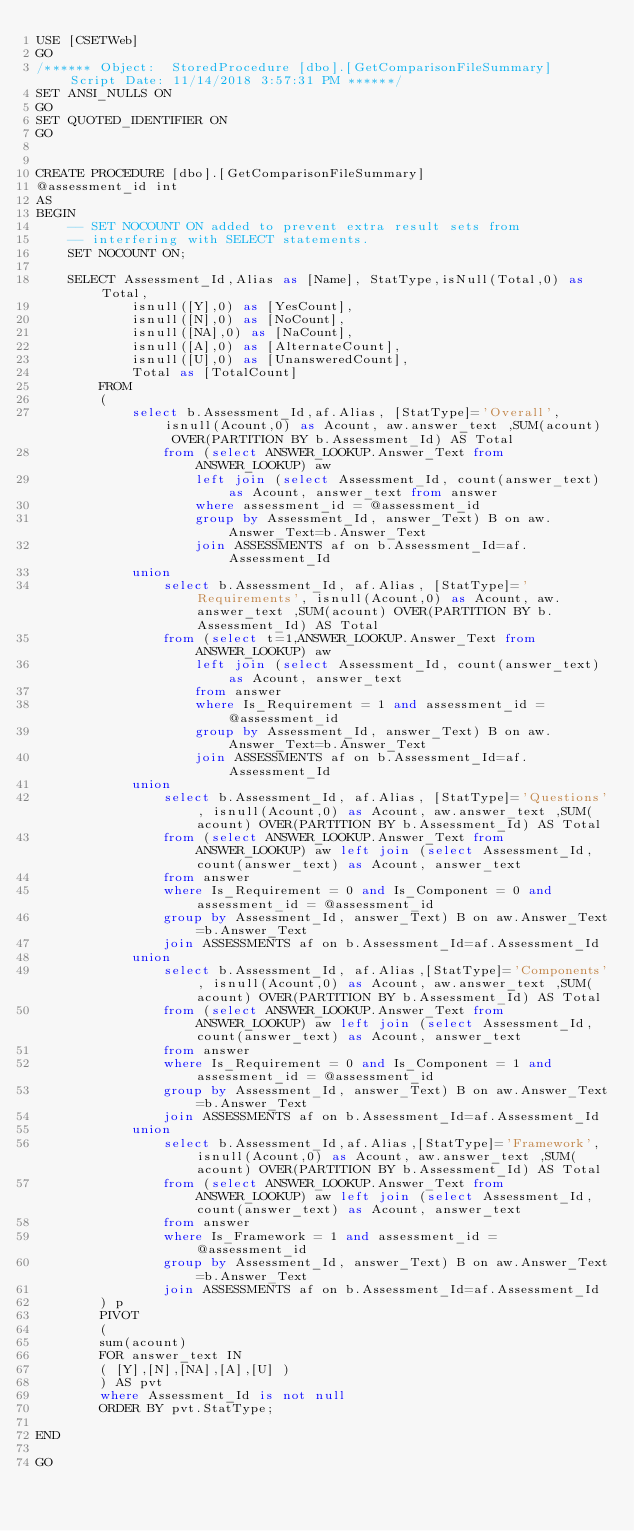Convert code to text. <code><loc_0><loc_0><loc_500><loc_500><_SQL_>USE [CSETWeb]
GO
/****** Object:  StoredProcedure [dbo].[GetComparisonFileSummary]    Script Date: 11/14/2018 3:57:31 PM ******/
SET ANSI_NULLS ON
GO
SET QUOTED_IDENTIFIER ON
GO


CREATE PROCEDURE [dbo].[GetComparisonFileSummary]	
@assessment_id int
AS
BEGIN
	-- SET NOCOUNT ON added to prevent extra result sets from
	-- interfering with SELECT statements.
	SET NOCOUNT ON;

	SELECT Assessment_Id,Alias as [Name], StatType,isNull(Total,0) as Total, 
			isnull([Y],0) as [YesCount],			
			isnull([N],0) as [NoCount],
			isnull([NA],0) as [NaCount],
			isnull([A],0) as [AlternateCount],
			isnull([U],0) as [UnansweredCount],			
			Total as [TotalCount]
		FROM 
		(
			select b.Assessment_Id,af.Alias, [StatType]='Overall', isnull(Acount,0) as Acount, aw.answer_text ,SUM(acount) OVER(PARTITION BY b.Assessment_Id) AS Total  
				from (select ANSWER_LOOKUP.Answer_Text from ANSWER_LOOKUP) aw 
					left join (select Assessment_Id, count(answer_text) as Acount, answer_text from answer 
					where assessment_id = @assessment_id
					group by Assessment_Id, answer_Text) B on aw.Answer_Text=b.Answer_Text 
					join ASSESSMENTS af on b.Assessment_Id=af.Assessment_Id
			union
				select b.Assessment_Id, af.Alias, [StatType]='Requirements', isnull(Acount,0) as Acount, aw.answer_text ,SUM(acount) OVER(PARTITION BY b.Assessment_Id) AS Total  		
				from (select t=1,ANSWER_LOOKUP.Answer_Text from ANSWER_LOOKUP) aw 
					left join (select Assessment_Id, count(answer_text) as Acount, answer_text
					from answer 
					where Is_Requirement = 1 and assessment_id = @assessment_id
					group by Assessment_Id, answer_Text) B on aw.Answer_Text=b.Answer_Text 
					join ASSESSMENTS af on b.Assessment_Id=af.Assessment_Id
			union
				select b.Assessment_Id, af.Alias, [StatType]='Questions', isnull(Acount,0) as Acount, aw.answer_text ,SUM(acount) OVER(PARTITION BY b.Assessment_Id) AS Total  
				from (select ANSWER_LOOKUP.Answer_Text from ANSWER_LOOKUP) aw left join (select Assessment_Id, count(answer_text) as Acount, answer_text
				from answer 
				where Is_Requirement = 0 and Is_Component = 0 and assessment_id = @assessment_id
				group by Assessment_Id, answer_Text) B on aw.Answer_Text=b.Answer_Text 	
				join ASSESSMENTS af on b.Assessment_Id=af.Assessment_Id
			union
				select b.Assessment_Id, af.Alias,[StatType]='Components', isnull(Acount,0) as Acount, aw.answer_text ,SUM(acount) OVER(PARTITION BY b.Assessment_Id) AS Total  
				from (select ANSWER_LOOKUP.Answer_Text from ANSWER_LOOKUP) aw left join (select Assessment_Id, count(answer_text) as Acount, answer_text
				from answer 
				where Is_Requirement = 0 and Is_Component = 1 and assessment_id = @assessment_id
				group by Assessment_Id, answer_Text) B on aw.Answer_Text=b.Answer_Text 
				join ASSESSMENTS af on b.Assessment_Id=af.Assessment_Id
			union
				select b.Assessment_Id,af.Alias,[StatType]='Framework', isnull(Acount,0) as Acount, aw.answer_text ,SUM(acount) OVER(PARTITION BY b.Assessment_Id) AS Total    
				from (select ANSWER_LOOKUP.Answer_Text from ANSWER_LOOKUP) aw left join (select Assessment_Id, count(answer_text) as Acount, answer_text
				from answer 
				where Is_Framework = 1 and assessment_id = @assessment_id
				group by Assessment_Id, answer_Text) B on aw.Answer_Text=b.Answer_Text 
				join ASSESSMENTS af on b.Assessment_Id=af.Assessment_Id
		) p
		PIVOT
		(
		sum(acount)
		FOR answer_text IN
		( [Y],[N],[NA],[A],[U] )
		) AS pvt
		where Assessment_Id is not null
		ORDER BY pvt.StatType;

END

GO
</code> 